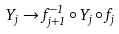<formula> <loc_0><loc_0><loc_500><loc_500>Y _ { j } \to f _ { j + 1 } ^ { - 1 } \circ Y _ { j } \circ f _ { j }</formula> 